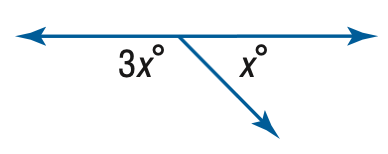Question: Find x.
Choices:
A. 45
B. 60
C. 90
D. 135
Answer with the letter. Answer: A 